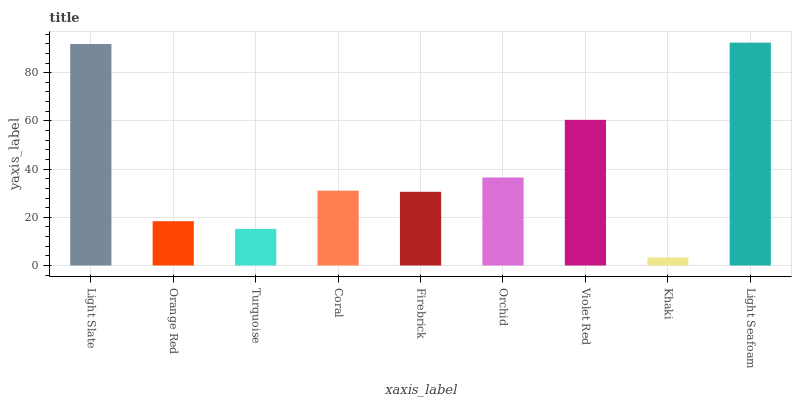Is Khaki the minimum?
Answer yes or no. Yes. Is Light Seafoam the maximum?
Answer yes or no. Yes. Is Orange Red the minimum?
Answer yes or no. No. Is Orange Red the maximum?
Answer yes or no. No. Is Light Slate greater than Orange Red?
Answer yes or no. Yes. Is Orange Red less than Light Slate?
Answer yes or no. Yes. Is Orange Red greater than Light Slate?
Answer yes or no. No. Is Light Slate less than Orange Red?
Answer yes or no. No. Is Coral the high median?
Answer yes or no. Yes. Is Coral the low median?
Answer yes or no. Yes. Is Light Slate the high median?
Answer yes or no. No. Is Violet Red the low median?
Answer yes or no. No. 